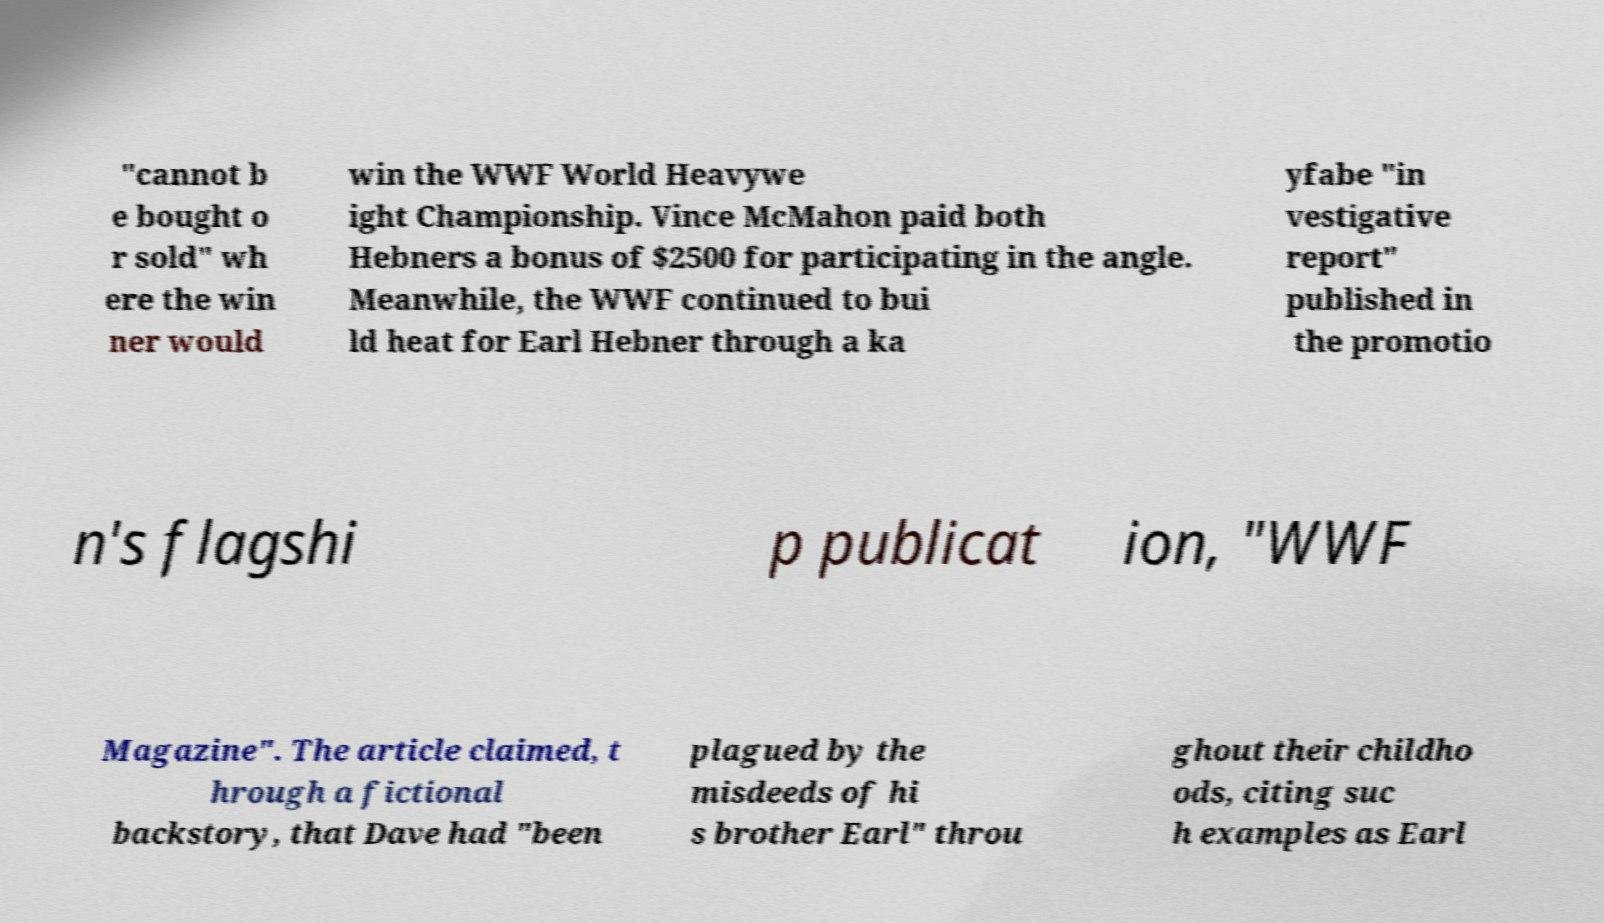Can you accurately transcribe the text from the provided image for me? "cannot b e bought o r sold" wh ere the win ner would win the WWF World Heavywe ight Championship. Vince McMahon paid both Hebners a bonus of $2500 for participating in the angle. Meanwhile, the WWF continued to bui ld heat for Earl Hebner through a ka yfabe "in vestigative report" published in the promotio n's flagshi p publicat ion, "WWF Magazine". The article claimed, t hrough a fictional backstory, that Dave had "been plagued by the misdeeds of hi s brother Earl" throu ghout their childho ods, citing suc h examples as Earl 